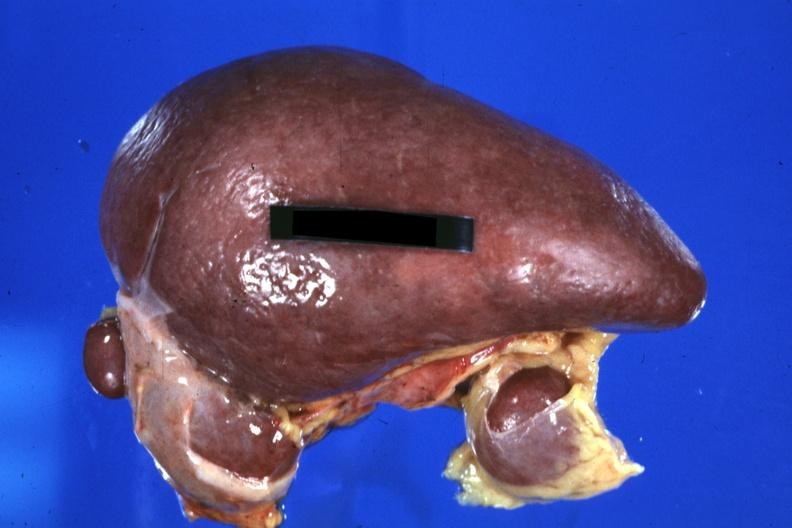how many accessories does this image show spleen with 32yobf left isomerism and complex congenital heart disease?
Answer the question using a single word or phrase. Three 